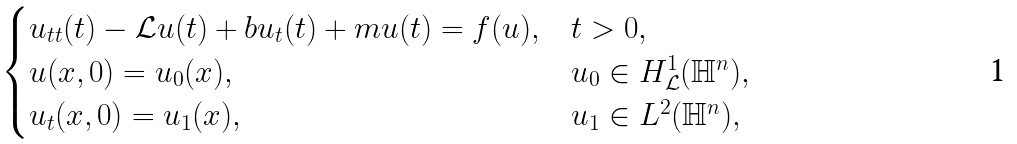<formula> <loc_0><loc_0><loc_500><loc_500>\begin{cases} u _ { t t } ( t ) - \mathcal { L } u ( t ) + b u _ { t } ( t ) + m u ( t ) = f ( u ) , & t > 0 , \\ u ( x , 0 ) = u _ { 0 } ( x ) , \, & u _ { 0 } \in H ^ { 1 } _ { \mathcal { L } } ( \mathbb { H } ^ { n } ) , \\ u _ { t } ( x , 0 ) = u _ { 1 } ( x ) , \, & u _ { 1 } \in L ^ { 2 } ( \mathbb { H } ^ { n } ) , \end{cases}</formula> 